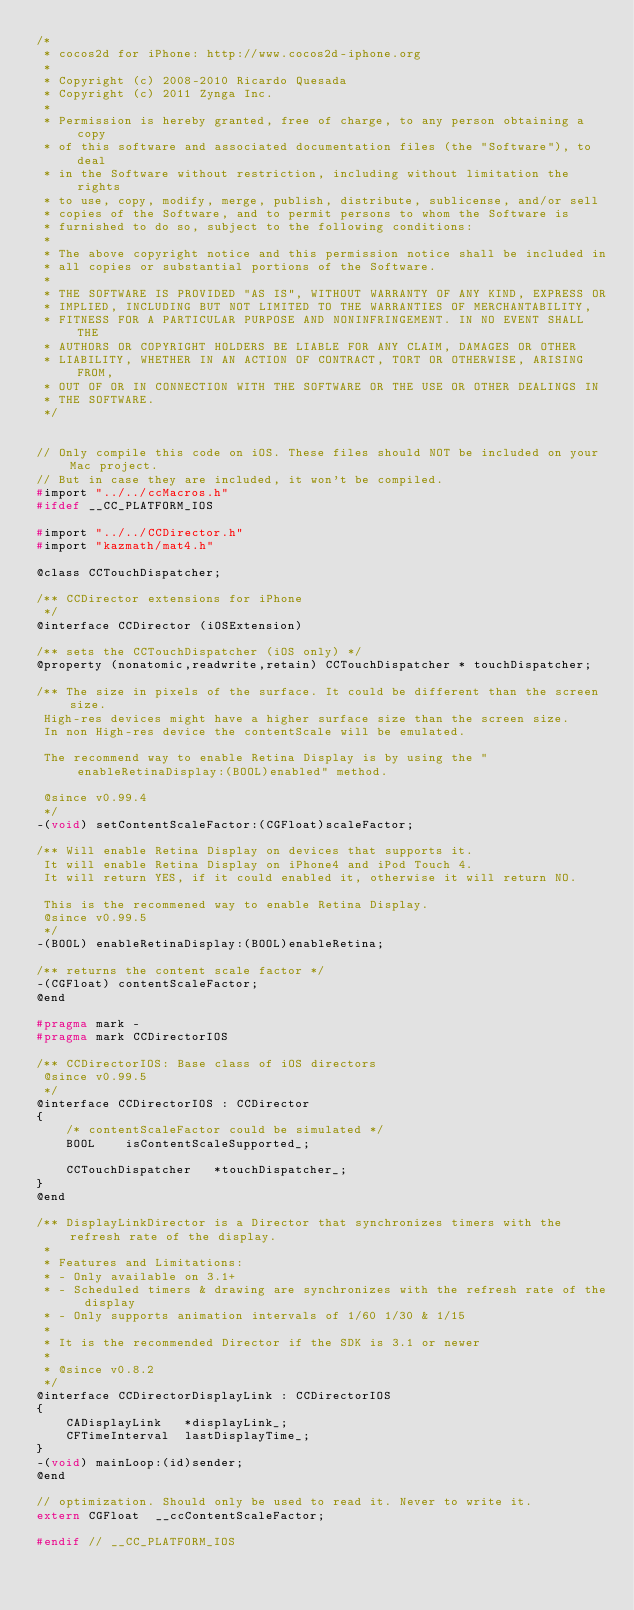Convert code to text. <code><loc_0><loc_0><loc_500><loc_500><_C_>/*
 * cocos2d for iPhone: http://www.cocos2d-iphone.org
 *
 * Copyright (c) 2008-2010 Ricardo Quesada
 * Copyright (c) 2011 Zynga Inc.
 *
 * Permission is hereby granted, free of charge, to any person obtaining a copy
 * of this software and associated documentation files (the "Software"), to deal
 * in the Software without restriction, including without limitation the rights
 * to use, copy, modify, merge, publish, distribute, sublicense, and/or sell
 * copies of the Software, and to permit persons to whom the Software is
 * furnished to do so, subject to the following conditions:
 *
 * The above copyright notice and this permission notice shall be included in
 * all copies or substantial portions of the Software.
 *
 * THE SOFTWARE IS PROVIDED "AS IS", WITHOUT WARRANTY OF ANY KIND, EXPRESS OR
 * IMPLIED, INCLUDING BUT NOT LIMITED TO THE WARRANTIES OF MERCHANTABILITY,
 * FITNESS FOR A PARTICULAR PURPOSE AND NONINFRINGEMENT. IN NO EVENT SHALL THE
 * AUTHORS OR COPYRIGHT HOLDERS BE LIABLE FOR ANY CLAIM, DAMAGES OR OTHER
 * LIABILITY, WHETHER IN AN ACTION OF CONTRACT, TORT OR OTHERWISE, ARISING FROM,
 * OUT OF OR IN CONNECTION WITH THE SOFTWARE OR THE USE OR OTHER DEALINGS IN
 * THE SOFTWARE.
 */


// Only compile this code on iOS. These files should NOT be included on your Mac project.
// But in case they are included, it won't be compiled.
#import "../../ccMacros.h"
#ifdef __CC_PLATFORM_IOS

#import "../../CCDirector.h"
#import "kazmath/mat4.h"

@class CCTouchDispatcher;

/** CCDirector extensions for iPhone
 */
@interface CCDirector (iOSExtension)

/** sets the CCTouchDispatcher (iOS only) */
@property (nonatomic,readwrite,retain) CCTouchDispatcher * touchDispatcher;

/** The size in pixels of the surface. It could be different than the screen size.
 High-res devices might have a higher surface size than the screen size.
 In non High-res device the contentScale will be emulated.

 The recommend way to enable Retina Display is by using the "enableRetinaDisplay:(BOOL)enabled" method.

 @since v0.99.4
 */
-(void) setContentScaleFactor:(CGFloat)scaleFactor;

/** Will enable Retina Display on devices that supports it.
 It will enable Retina Display on iPhone4 and iPod Touch 4.
 It will return YES, if it could enabled it, otherwise it will return NO.

 This is the recommened way to enable Retina Display.
 @since v0.99.5
 */
-(BOOL) enableRetinaDisplay:(BOOL)enableRetina;

/** returns the content scale factor */
-(CGFloat) contentScaleFactor;
@end

#pragma mark -
#pragma mark CCDirectorIOS

/** CCDirectorIOS: Base class of iOS directors
 @since v0.99.5
 */
@interface CCDirectorIOS : CCDirector
{
	/* contentScaleFactor could be simulated */
	BOOL	isContentScaleSupported_;
	
	CCTouchDispatcher	*touchDispatcher_;
}
@end

/** DisplayLinkDirector is a Director that synchronizes timers with the refresh rate of the display.
 *
 * Features and Limitations:
 * - Only available on 3.1+
 * - Scheduled timers & drawing are synchronizes with the refresh rate of the display
 * - Only supports animation intervals of 1/60 1/30 & 1/15
 *
 * It is the recommended Director if the SDK is 3.1 or newer
 *
 * @since v0.8.2
 */
@interface CCDirectorDisplayLink : CCDirectorIOS
{
	CADisplayLink	*displayLink_;
	CFTimeInterval	lastDisplayTime_;
}
-(void) mainLoop:(id)sender;
@end

// optimization. Should only be used to read it. Never to write it.
extern CGFloat	__ccContentScaleFactor;

#endif // __CC_PLATFORM_IOS
</code> 